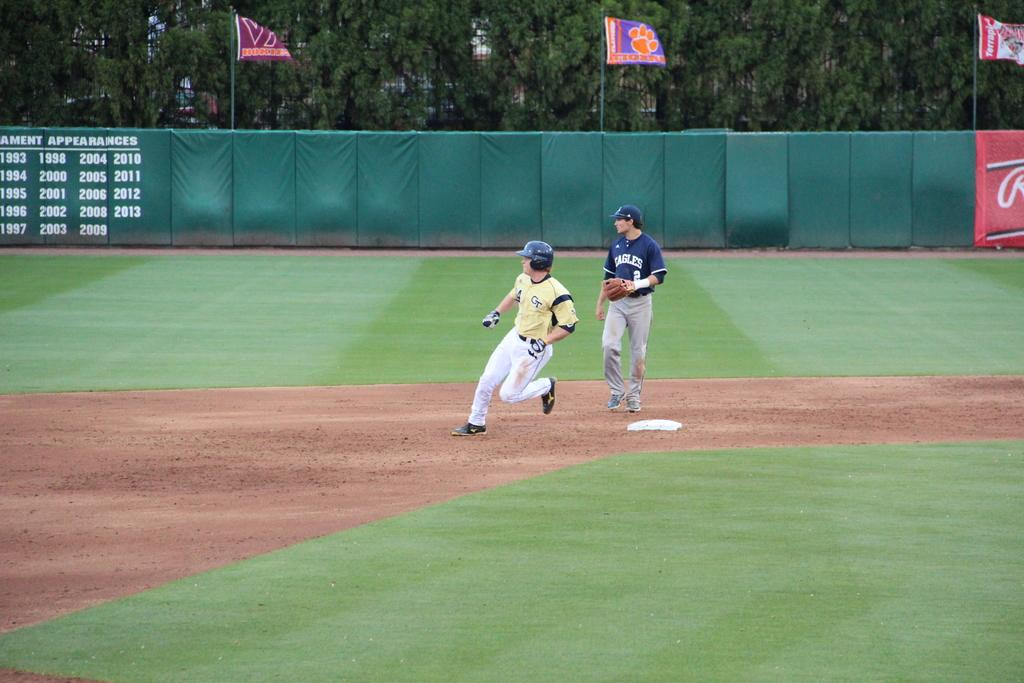How many people are present in the image? There are two people on the ground in the image. What can be seen in the background of the image? There are flags, boards, and trees in the background of the image. What type of yarn is being used by the people in the image? There is no yarn present in the image; the people are not engaged in any activity involving yarn. 